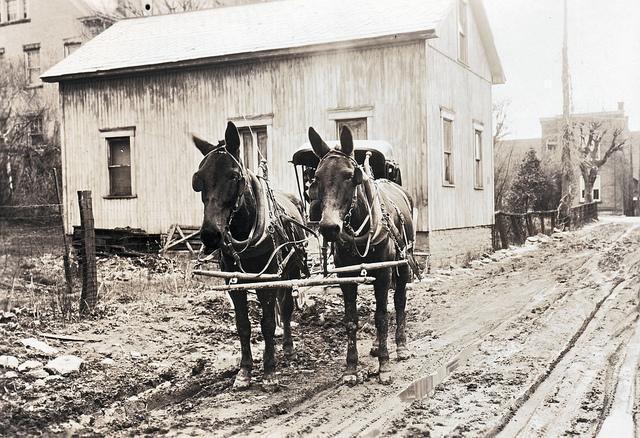How many horses are visible?
Give a very brief answer. 2. How many people are in this picture?
Give a very brief answer. 0. 